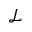Convert formula to latex. <formula><loc_0><loc_0><loc_500><loc_500>\mathcal { L }</formula> 